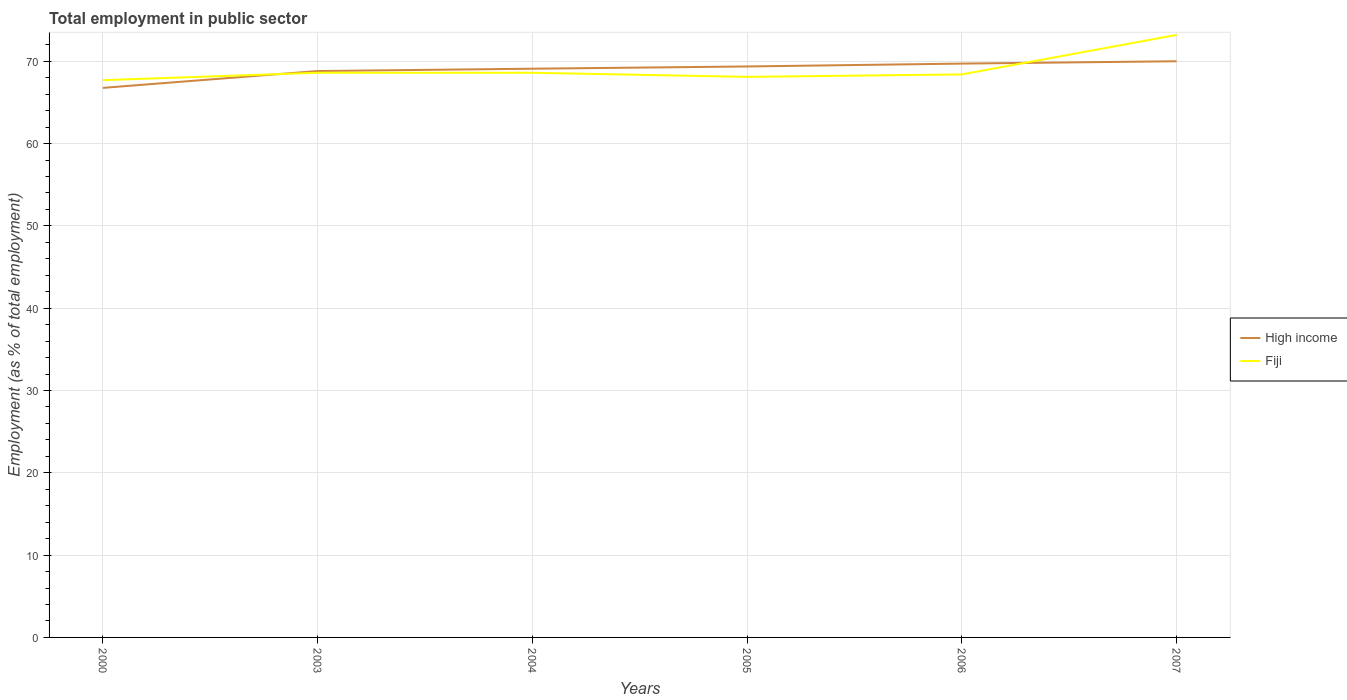Does the line corresponding to High income intersect with the line corresponding to Fiji?
Make the answer very short. Yes. Across all years, what is the maximum employment in public sector in High income?
Offer a very short reply. 66.76. What is the total employment in public sector in Fiji in the graph?
Provide a succinct answer. 0.2. What is the difference between the highest and the second highest employment in public sector in Fiji?
Offer a terse response. 5.5. Is the employment in public sector in High income strictly greater than the employment in public sector in Fiji over the years?
Provide a short and direct response. No. Are the values on the major ticks of Y-axis written in scientific E-notation?
Make the answer very short. No. Where does the legend appear in the graph?
Keep it short and to the point. Center right. What is the title of the graph?
Make the answer very short. Total employment in public sector. Does "Israel" appear as one of the legend labels in the graph?
Offer a very short reply. No. What is the label or title of the Y-axis?
Your answer should be very brief. Employment (as % of total employment). What is the Employment (as % of total employment) of High income in 2000?
Keep it short and to the point. 66.76. What is the Employment (as % of total employment) of Fiji in 2000?
Your response must be concise. 67.7. What is the Employment (as % of total employment) of High income in 2003?
Provide a succinct answer. 68.81. What is the Employment (as % of total employment) in Fiji in 2003?
Your answer should be compact. 68.6. What is the Employment (as % of total employment) of High income in 2004?
Make the answer very short. 69.09. What is the Employment (as % of total employment) of Fiji in 2004?
Provide a succinct answer. 68.6. What is the Employment (as % of total employment) of High income in 2005?
Your answer should be compact. 69.36. What is the Employment (as % of total employment) of Fiji in 2005?
Keep it short and to the point. 68.1. What is the Employment (as % of total employment) of High income in 2006?
Offer a very short reply. 69.71. What is the Employment (as % of total employment) in Fiji in 2006?
Provide a succinct answer. 68.4. What is the Employment (as % of total employment) of High income in 2007?
Keep it short and to the point. 70. What is the Employment (as % of total employment) of Fiji in 2007?
Your answer should be very brief. 73.2. Across all years, what is the maximum Employment (as % of total employment) in High income?
Your answer should be compact. 70. Across all years, what is the maximum Employment (as % of total employment) in Fiji?
Keep it short and to the point. 73.2. Across all years, what is the minimum Employment (as % of total employment) of High income?
Keep it short and to the point. 66.76. Across all years, what is the minimum Employment (as % of total employment) in Fiji?
Offer a terse response. 67.7. What is the total Employment (as % of total employment) of High income in the graph?
Your response must be concise. 413.74. What is the total Employment (as % of total employment) of Fiji in the graph?
Provide a short and direct response. 414.6. What is the difference between the Employment (as % of total employment) of High income in 2000 and that in 2003?
Your answer should be compact. -2.04. What is the difference between the Employment (as % of total employment) of High income in 2000 and that in 2004?
Offer a very short reply. -2.33. What is the difference between the Employment (as % of total employment) in High income in 2000 and that in 2005?
Offer a very short reply. -2.6. What is the difference between the Employment (as % of total employment) of Fiji in 2000 and that in 2005?
Offer a very short reply. -0.4. What is the difference between the Employment (as % of total employment) of High income in 2000 and that in 2006?
Offer a very short reply. -2.95. What is the difference between the Employment (as % of total employment) in Fiji in 2000 and that in 2006?
Provide a succinct answer. -0.7. What is the difference between the Employment (as % of total employment) of High income in 2000 and that in 2007?
Keep it short and to the point. -3.23. What is the difference between the Employment (as % of total employment) in High income in 2003 and that in 2004?
Ensure brevity in your answer.  -0.28. What is the difference between the Employment (as % of total employment) in Fiji in 2003 and that in 2004?
Ensure brevity in your answer.  0. What is the difference between the Employment (as % of total employment) in High income in 2003 and that in 2005?
Give a very brief answer. -0.56. What is the difference between the Employment (as % of total employment) of Fiji in 2003 and that in 2005?
Provide a short and direct response. 0.5. What is the difference between the Employment (as % of total employment) of High income in 2003 and that in 2006?
Your answer should be compact. -0.91. What is the difference between the Employment (as % of total employment) in High income in 2003 and that in 2007?
Offer a terse response. -1.19. What is the difference between the Employment (as % of total employment) in Fiji in 2003 and that in 2007?
Ensure brevity in your answer.  -4.6. What is the difference between the Employment (as % of total employment) of High income in 2004 and that in 2005?
Your response must be concise. -0.27. What is the difference between the Employment (as % of total employment) in Fiji in 2004 and that in 2005?
Give a very brief answer. 0.5. What is the difference between the Employment (as % of total employment) of High income in 2004 and that in 2006?
Provide a short and direct response. -0.62. What is the difference between the Employment (as % of total employment) in High income in 2004 and that in 2007?
Your answer should be compact. -0.91. What is the difference between the Employment (as % of total employment) of High income in 2005 and that in 2006?
Your answer should be very brief. -0.35. What is the difference between the Employment (as % of total employment) in High income in 2005 and that in 2007?
Keep it short and to the point. -0.63. What is the difference between the Employment (as % of total employment) in High income in 2006 and that in 2007?
Keep it short and to the point. -0.28. What is the difference between the Employment (as % of total employment) of Fiji in 2006 and that in 2007?
Keep it short and to the point. -4.8. What is the difference between the Employment (as % of total employment) of High income in 2000 and the Employment (as % of total employment) of Fiji in 2003?
Your response must be concise. -1.84. What is the difference between the Employment (as % of total employment) of High income in 2000 and the Employment (as % of total employment) of Fiji in 2004?
Your answer should be compact. -1.84. What is the difference between the Employment (as % of total employment) of High income in 2000 and the Employment (as % of total employment) of Fiji in 2005?
Keep it short and to the point. -1.34. What is the difference between the Employment (as % of total employment) of High income in 2000 and the Employment (as % of total employment) of Fiji in 2006?
Offer a terse response. -1.64. What is the difference between the Employment (as % of total employment) of High income in 2000 and the Employment (as % of total employment) of Fiji in 2007?
Ensure brevity in your answer.  -6.44. What is the difference between the Employment (as % of total employment) of High income in 2003 and the Employment (as % of total employment) of Fiji in 2004?
Ensure brevity in your answer.  0.21. What is the difference between the Employment (as % of total employment) in High income in 2003 and the Employment (as % of total employment) in Fiji in 2005?
Offer a terse response. 0.71. What is the difference between the Employment (as % of total employment) of High income in 2003 and the Employment (as % of total employment) of Fiji in 2006?
Your answer should be very brief. 0.41. What is the difference between the Employment (as % of total employment) of High income in 2003 and the Employment (as % of total employment) of Fiji in 2007?
Provide a short and direct response. -4.39. What is the difference between the Employment (as % of total employment) of High income in 2004 and the Employment (as % of total employment) of Fiji in 2005?
Give a very brief answer. 0.99. What is the difference between the Employment (as % of total employment) in High income in 2004 and the Employment (as % of total employment) in Fiji in 2006?
Provide a succinct answer. 0.69. What is the difference between the Employment (as % of total employment) of High income in 2004 and the Employment (as % of total employment) of Fiji in 2007?
Offer a terse response. -4.11. What is the difference between the Employment (as % of total employment) of High income in 2005 and the Employment (as % of total employment) of Fiji in 2006?
Your response must be concise. 0.96. What is the difference between the Employment (as % of total employment) of High income in 2005 and the Employment (as % of total employment) of Fiji in 2007?
Give a very brief answer. -3.84. What is the difference between the Employment (as % of total employment) of High income in 2006 and the Employment (as % of total employment) of Fiji in 2007?
Keep it short and to the point. -3.49. What is the average Employment (as % of total employment) of High income per year?
Your answer should be compact. 68.96. What is the average Employment (as % of total employment) in Fiji per year?
Provide a short and direct response. 69.1. In the year 2000, what is the difference between the Employment (as % of total employment) in High income and Employment (as % of total employment) in Fiji?
Make the answer very short. -0.94. In the year 2003, what is the difference between the Employment (as % of total employment) of High income and Employment (as % of total employment) of Fiji?
Your answer should be compact. 0.21. In the year 2004, what is the difference between the Employment (as % of total employment) in High income and Employment (as % of total employment) in Fiji?
Ensure brevity in your answer.  0.49. In the year 2005, what is the difference between the Employment (as % of total employment) in High income and Employment (as % of total employment) in Fiji?
Give a very brief answer. 1.26. In the year 2006, what is the difference between the Employment (as % of total employment) in High income and Employment (as % of total employment) in Fiji?
Give a very brief answer. 1.31. In the year 2007, what is the difference between the Employment (as % of total employment) of High income and Employment (as % of total employment) of Fiji?
Your response must be concise. -3.2. What is the ratio of the Employment (as % of total employment) of High income in 2000 to that in 2003?
Keep it short and to the point. 0.97. What is the ratio of the Employment (as % of total employment) in Fiji in 2000 to that in 2003?
Keep it short and to the point. 0.99. What is the ratio of the Employment (as % of total employment) of High income in 2000 to that in 2004?
Ensure brevity in your answer.  0.97. What is the ratio of the Employment (as % of total employment) of Fiji in 2000 to that in 2004?
Offer a terse response. 0.99. What is the ratio of the Employment (as % of total employment) of High income in 2000 to that in 2005?
Provide a succinct answer. 0.96. What is the ratio of the Employment (as % of total employment) of Fiji in 2000 to that in 2005?
Keep it short and to the point. 0.99. What is the ratio of the Employment (as % of total employment) of High income in 2000 to that in 2006?
Offer a terse response. 0.96. What is the ratio of the Employment (as % of total employment) in Fiji in 2000 to that in 2006?
Provide a succinct answer. 0.99. What is the ratio of the Employment (as % of total employment) in High income in 2000 to that in 2007?
Your answer should be compact. 0.95. What is the ratio of the Employment (as % of total employment) in Fiji in 2000 to that in 2007?
Ensure brevity in your answer.  0.92. What is the ratio of the Employment (as % of total employment) in Fiji in 2003 to that in 2004?
Keep it short and to the point. 1. What is the ratio of the Employment (as % of total employment) in Fiji in 2003 to that in 2005?
Make the answer very short. 1.01. What is the ratio of the Employment (as % of total employment) in Fiji in 2003 to that in 2006?
Provide a succinct answer. 1. What is the ratio of the Employment (as % of total employment) of Fiji in 2003 to that in 2007?
Ensure brevity in your answer.  0.94. What is the ratio of the Employment (as % of total employment) in Fiji in 2004 to that in 2005?
Provide a short and direct response. 1.01. What is the ratio of the Employment (as % of total employment) in Fiji in 2004 to that in 2006?
Give a very brief answer. 1. What is the ratio of the Employment (as % of total employment) of High income in 2004 to that in 2007?
Your answer should be compact. 0.99. What is the ratio of the Employment (as % of total employment) of Fiji in 2004 to that in 2007?
Make the answer very short. 0.94. What is the ratio of the Employment (as % of total employment) of High income in 2005 to that in 2006?
Offer a very short reply. 0.99. What is the ratio of the Employment (as % of total employment) in Fiji in 2005 to that in 2006?
Give a very brief answer. 1. What is the ratio of the Employment (as % of total employment) of High income in 2005 to that in 2007?
Provide a succinct answer. 0.99. What is the ratio of the Employment (as % of total employment) in Fiji in 2005 to that in 2007?
Provide a short and direct response. 0.93. What is the ratio of the Employment (as % of total employment) of Fiji in 2006 to that in 2007?
Your answer should be compact. 0.93. What is the difference between the highest and the second highest Employment (as % of total employment) of High income?
Your response must be concise. 0.28. What is the difference between the highest and the lowest Employment (as % of total employment) in High income?
Make the answer very short. 3.23. 